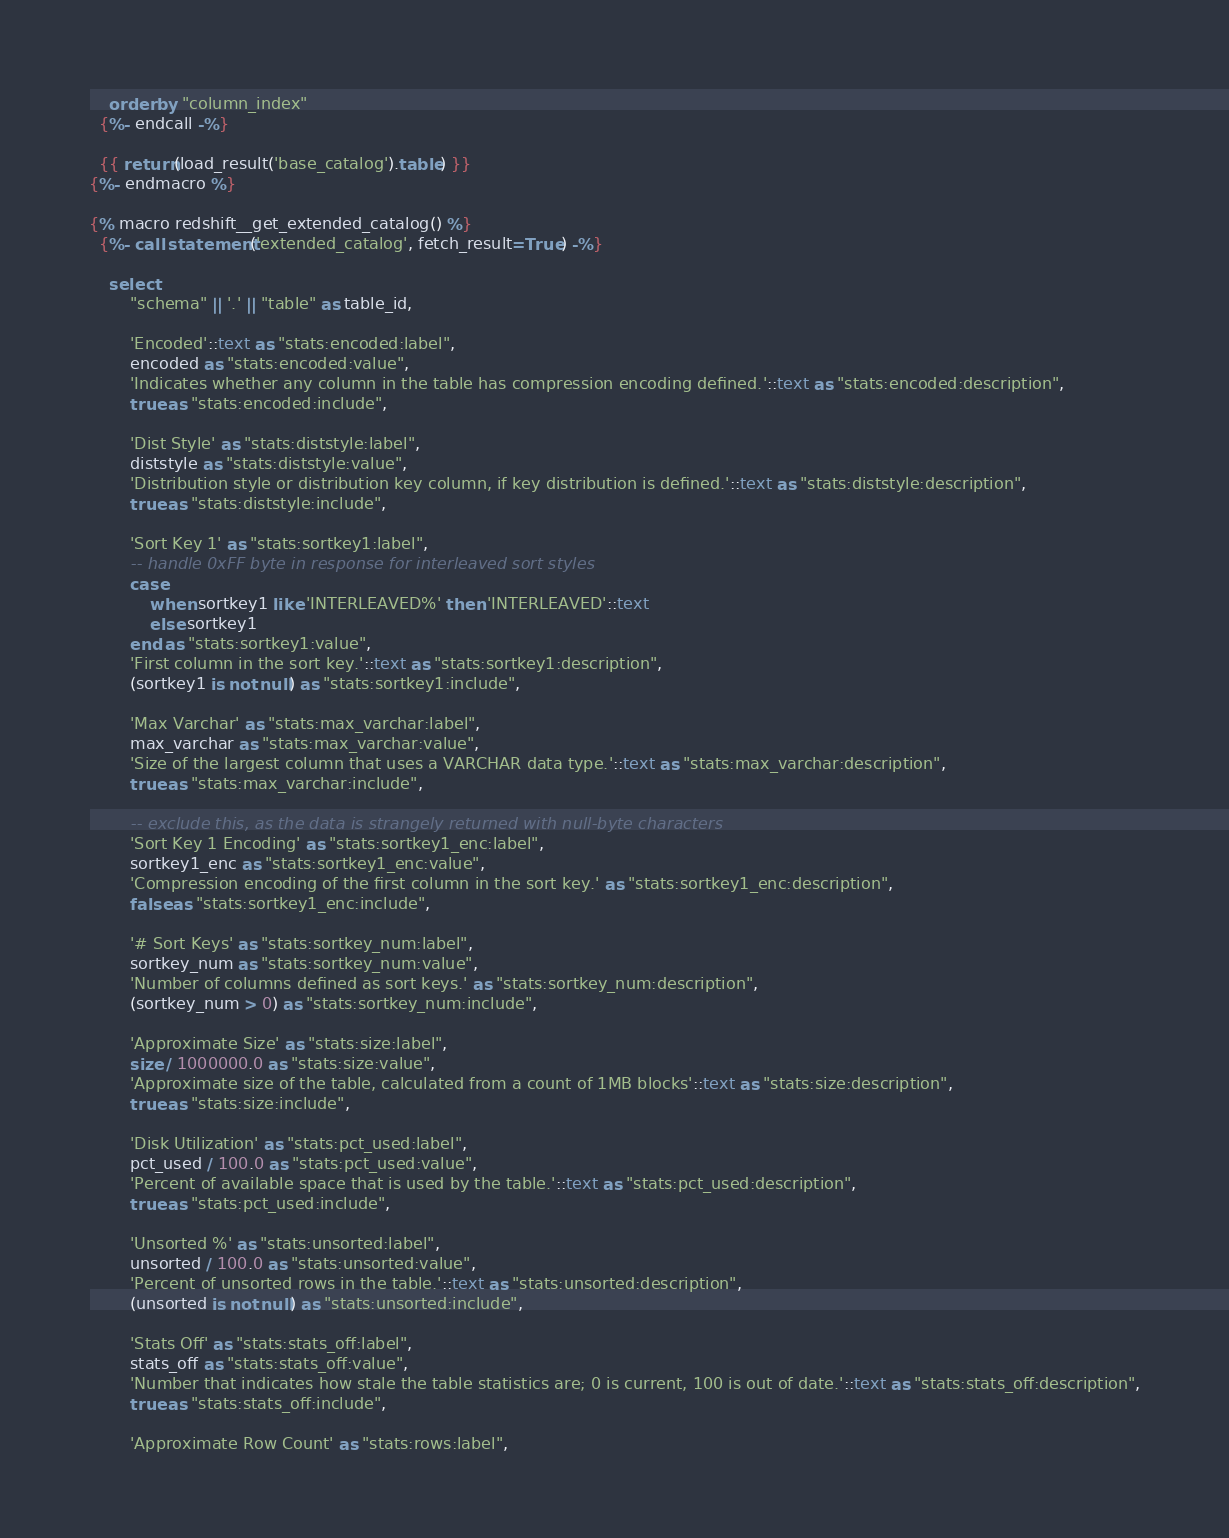<code> <loc_0><loc_0><loc_500><loc_500><_SQL_>    order by "column_index"
  {%- endcall -%}

  {{ return(load_result('base_catalog').table) }}
{%- endmacro %}

{% macro redshift__get_extended_catalog() %}
  {%- call statement('extended_catalog', fetch_result=True) -%}

    select
        "schema" || '.' || "table" as table_id,

        'Encoded'::text as "stats:encoded:label",
        encoded as "stats:encoded:value",
        'Indicates whether any column in the table has compression encoding defined.'::text as "stats:encoded:description",
        true as "stats:encoded:include",

        'Dist Style' as "stats:diststyle:label",
        diststyle as "stats:diststyle:value",
        'Distribution style or distribution key column, if key distribution is defined.'::text as "stats:diststyle:description",
        true as "stats:diststyle:include",

        'Sort Key 1' as "stats:sortkey1:label",
        -- handle 0xFF byte in response for interleaved sort styles
        case
            when sortkey1 like 'INTERLEAVED%' then 'INTERLEAVED'::text
            else sortkey1
        end as "stats:sortkey1:value",
        'First column in the sort key.'::text as "stats:sortkey1:description",
        (sortkey1 is not null) as "stats:sortkey1:include",

        'Max Varchar' as "stats:max_varchar:label",
        max_varchar as "stats:max_varchar:value",
        'Size of the largest column that uses a VARCHAR data type.'::text as "stats:max_varchar:description",
        true as "stats:max_varchar:include",

        -- exclude this, as the data is strangely returned with null-byte characters
        'Sort Key 1 Encoding' as "stats:sortkey1_enc:label",
        sortkey1_enc as "stats:sortkey1_enc:value",
        'Compression encoding of the first column in the sort key.' as "stats:sortkey1_enc:description",
        false as "stats:sortkey1_enc:include",

        '# Sort Keys' as "stats:sortkey_num:label",
        sortkey_num as "stats:sortkey_num:value",
        'Number of columns defined as sort keys.' as "stats:sortkey_num:description",
        (sortkey_num > 0) as "stats:sortkey_num:include",

        'Approximate Size' as "stats:size:label",
        size / 1000000.0 as "stats:size:value",
        'Approximate size of the table, calculated from a count of 1MB blocks'::text as "stats:size:description",
        true as "stats:size:include",

        'Disk Utilization' as "stats:pct_used:label",
        pct_used / 100.0 as "stats:pct_used:value",
        'Percent of available space that is used by the table.'::text as "stats:pct_used:description",
        true as "stats:pct_used:include",

        'Unsorted %' as "stats:unsorted:label",
        unsorted / 100.0 as "stats:unsorted:value",
        'Percent of unsorted rows in the table.'::text as "stats:unsorted:description",
        (unsorted is not null) as "stats:unsorted:include",

        'Stats Off' as "stats:stats_off:label",
        stats_off as "stats:stats_off:value",
        'Number that indicates how stale the table statistics are; 0 is current, 100 is out of date.'::text as "stats:stats_off:description",
        true as "stats:stats_off:include",

        'Approximate Row Count' as "stats:rows:label",</code> 